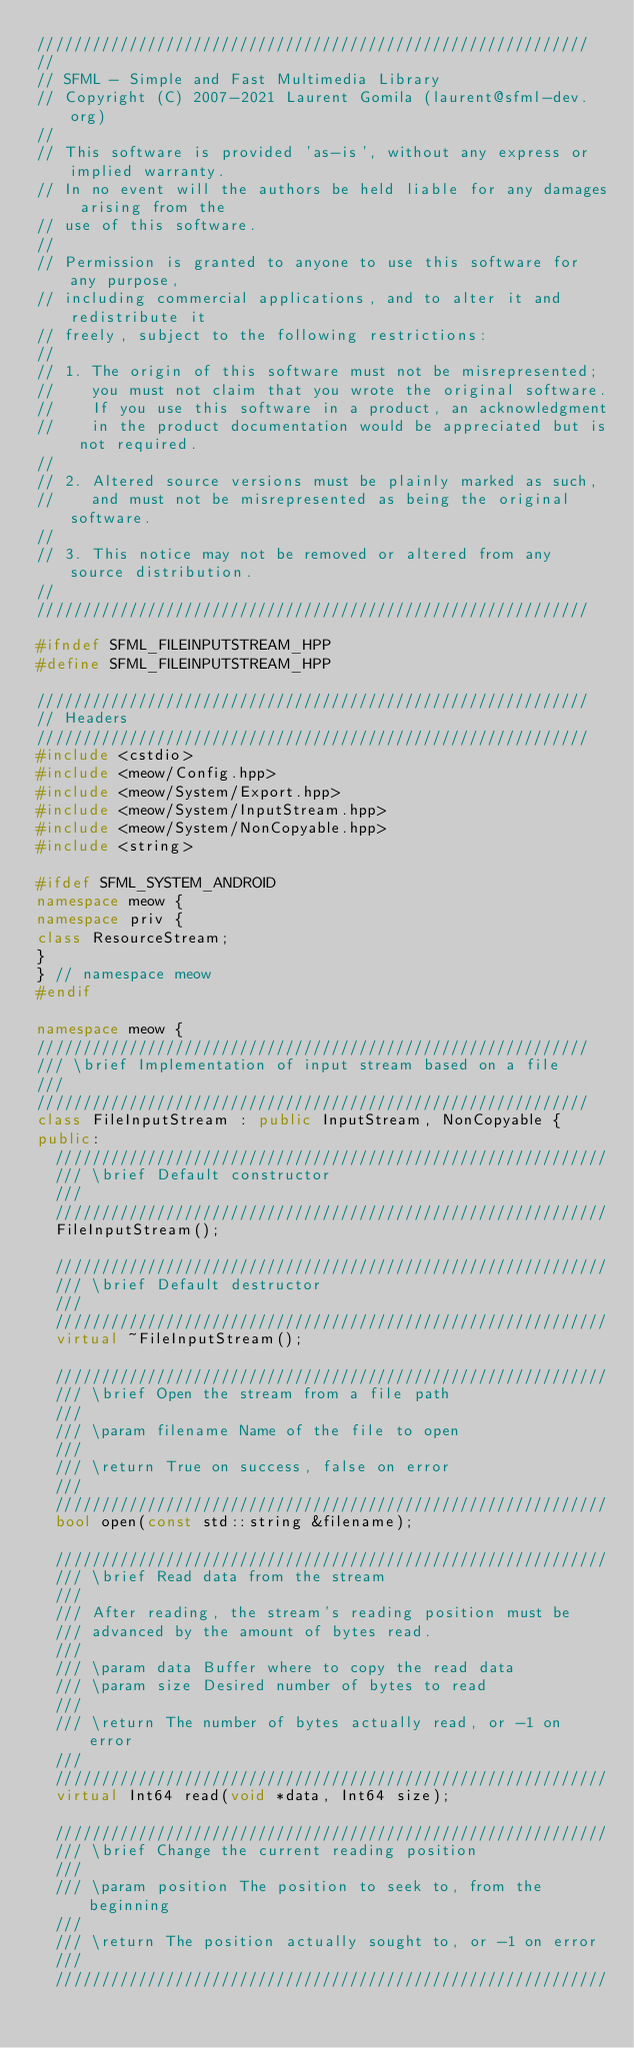<code> <loc_0><loc_0><loc_500><loc_500><_C++_>////////////////////////////////////////////////////////////
//
// SFML - Simple and Fast Multimedia Library
// Copyright (C) 2007-2021 Laurent Gomila (laurent@sfml-dev.org)
//
// This software is provided 'as-is', without any express or implied warranty.
// In no event will the authors be held liable for any damages arising from the
// use of this software.
//
// Permission is granted to anyone to use this software for any purpose,
// including commercial applications, and to alter it and redistribute it
// freely, subject to the following restrictions:
//
// 1. The origin of this software must not be misrepresented;
//    you must not claim that you wrote the original software.
//    If you use this software in a product, an acknowledgment
//    in the product documentation would be appreciated but is not required.
//
// 2. Altered source versions must be plainly marked as such,
//    and must not be misrepresented as being the original software.
//
// 3. This notice may not be removed or altered from any source distribution.
//
////////////////////////////////////////////////////////////

#ifndef SFML_FILEINPUTSTREAM_HPP
#define SFML_FILEINPUTSTREAM_HPP

////////////////////////////////////////////////////////////
// Headers
////////////////////////////////////////////////////////////
#include <cstdio>
#include <meow/Config.hpp>
#include <meow/System/Export.hpp>
#include <meow/System/InputStream.hpp>
#include <meow/System/NonCopyable.hpp>
#include <string>

#ifdef SFML_SYSTEM_ANDROID
namespace meow {
namespace priv {
class ResourceStream;
}
} // namespace meow
#endif

namespace meow {
////////////////////////////////////////////////////////////
/// \brief Implementation of input stream based on a file
///
////////////////////////////////////////////////////////////
class FileInputStream : public InputStream, NonCopyable {
public:
  ////////////////////////////////////////////////////////////
  /// \brief Default constructor
  ///
  ////////////////////////////////////////////////////////////
  FileInputStream();

  ////////////////////////////////////////////////////////////
  /// \brief Default destructor
  ///
  ////////////////////////////////////////////////////////////
  virtual ~FileInputStream();

  ////////////////////////////////////////////////////////////
  /// \brief Open the stream from a file path
  ///
  /// \param filename Name of the file to open
  ///
  /// \return True on success, false on error
  ///
  ////////////////////////////////////////////////////////////
  bool open(const std::string &filename);

  ////////////////////////////////////////////////////////////
  /// \brief Read data from the stream
  ///
  /// After reading, the stream's reading position must be
  /// advanced by the amount of bytes read.
  ///
  /// \param data Buffer where to copy the read data
  /// \param size Desired number of bytes to read
  ///
  /// \return The number of bytes actually read, or -1 on error
  ///
  ////////////////////////////////////////////////////////////
  virtual Int64 read(void *data, Int64 size);

  ////////////////////////////////////////////////////////////
  /// \brief Change the current reading position
  ///
  /// \param position The position to seek to, from the beginning
  ///
  /// \return The position actually sought to, or -1 on error
  ///
  ////////////////////////////////////////////////////////////</code> 